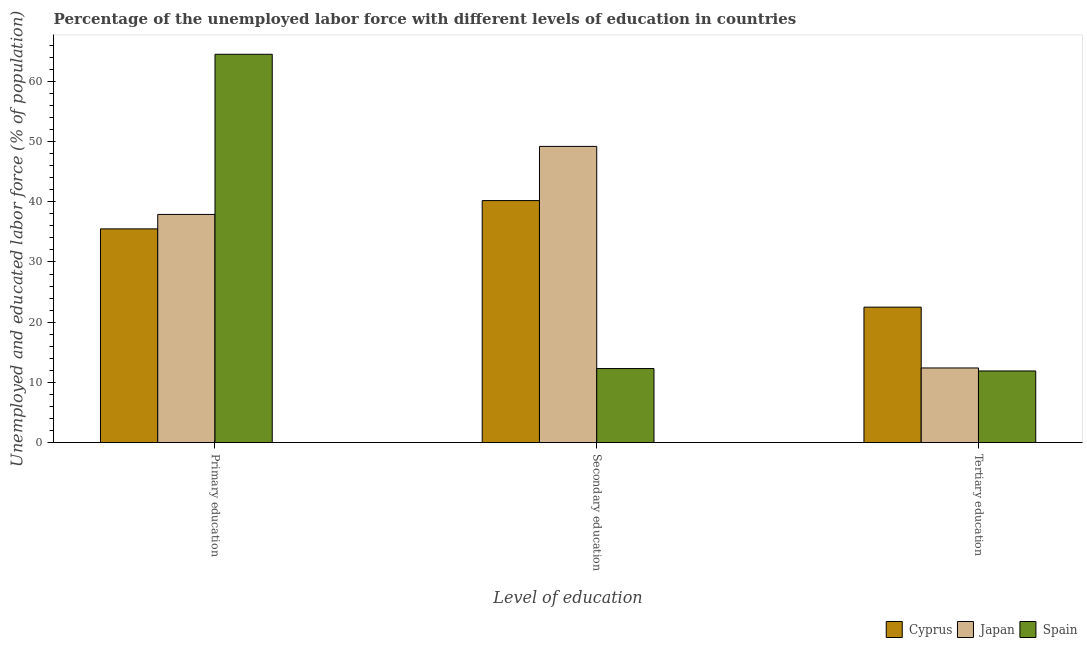How many different coloured bars are there?
Your answer should be very brief. 3. How many groups of bars are there?
Make the answer very short. 3. Are the number of bars on each tick of the X-axis equal?
Your answer should be very brief. Yes. How many bars are there on the 3rd tick from the left?
Your answer should be very brief. 3. How many bars are there on the 1st tick from the right?
Offer a very short reply. 3. What is the label of the 2nd group of bars from the left?
Your answer should be very brief. Secondary education. What is the percentage of labor force who received secondary education in Spain?
Offer a terse response. 12.3. Across all countries, what is the maximum percentage of labor force who received secondary education?
Your answer should be very brief. 49.2. Across all countries, what is the minimum percentage of labor force who received primary education?
Provide a short and direct response. 35.5. In which country was the percentage of labor force who received secondary education minimum?
Offer a terse response. Spain. What is the total percentage of labor force who received tertiary education in the graph?
Offer a terse response. 46.8. What is the difference between the percentage of labor force who received tertiary education in Spain and that in Cyprus?
Offer a very short reply. -10.6. What is the difference between the percentage of labor force who received primary education in Spain and the percentage of labor force who received tertiary education in Cyprus?
Your answer should be compact. 42. What is the average percentage of labor force who received secondary education per country?
Your answer should be very brief. 33.9. What is the difference between the percentage of labor force who received tertiary education and percentage of labor force who received primary education in Japan?
Offer a very short reply. -25.5. What is the ratio of the percentage of labor force who received primary education in Japan to that in Cyprus?
Keep it short and to the point. 1.07. Is the percentage of labor force who received secondary education in Japan less than that in Cyprus?
Your response must be concise. No. Is the difference between the percentage of labor force who received primary education in Japan and Spain greater than the difference between the percentage of labor force who received secondary education in Japan and Spain?
Your answer should be compact. No. What is the difference between the highest and the second highest percentage of labor force who received tertiary education?
Provide a short and direct response. 10.1. In how many countries, is the percentage of labor force who received secondary education greater than the average percentage of labor force who received secondary education taken over all countries?
Provide a succinct answer. 2. What does the 3rd bar from the left in Tertiary education represents?
Your answer should be compact. Spain. What does the 1st bar from the right in Primary education represents?
Keep it short and to the point. Spain. How many countries are there in the graph?
Keep it short and to the point. 3. Where does the legend appear in the graph?
Keep it short and to the point. Bottom right. How many legend labels are there?
Your answer should be very brief. 3. What is the title of the graph?
Your response must be concise. Percentage of the unemployed labor force with different levels of education in countries. What is the label or title of the X-axis?
Offer a very short reply. Level of education. What is the label or title of the Y-axis?
Offer a very short reply. Unemployed and educated labor force (% of population). What is the Unemployed and educated labor force (% of population) in Cyprus in Primary education?
Offer a very short reply. 35.5. What is the Unemployed and educated labor force (% of population) in Japan in Primary education?
Give a very brief answer. 37.9. What is the Unemployed and educated labor force (% of population) in Spain in Primary education?
Offer a terse response. 64.5. What is the Unemployed and educated labor force (% of population) of Cyprus in Secondary education?
Keep it short and to the point. 40.2. What is the Unemployed and educated labor force (% of population) in Japan in Secondary education?
Ensure brevity in your answer.  49.2. What is the Unemployed and educated labor force (% of population) of Spain in Secondary education?
Your answer should be very brief. 12.3. What is the Unemployed and educated labor force (% of population) in Japan in Tertiary education?
Your answer should be compact. 12.4. What is the Unemployed and educated labor force (% of population) of Spain in Tertiary education?
Provide a succinct answer. 11.9. Across all Level of education, what is the maximum Unemployed and educated labor force (% of population) of Cyprus?
Ensure brevity in your answer.  40.2. Across all Level of education, what is the maximum Unemployed and educated labor force (% of population) of Japan?
Offer a very short reply. 49.2. Across all Level of education, what is the maximum Unemployed and educated labor force (% of population) in Spain?
Offer a very short reply. 64.5. Across all Level of education, what is the minimum Unemployed and educated labor force (% of population) in Japan?
Ensure brevity in your answer.  12.4. Across all Level of education, what is the minimum Unemployed and educated labor force (% of population) in Spain?
Offer a terse response. 11.9. What is the total Unemployed and educated labor force (% of population) of Cyprus in the graph?
Make the answer very short. 98.2. What is the total Unemployed and educated labor force (% of population) of Japan in the graph?
Your response must be concise. 99.5. What is the total Unemployed and educated labor force (% of population) of Spain in the graph?
Your answer should be very brief. 88.7. What is the difference between the Unemployed and educated labor force (% of population) in Spain in Primary education and that in Secondary education?
Provide a succinct answer. 52.2. What is the difference between the Unemployed and educated labor force (% of population) in Cyprus in Primary education and that in Tertiary education?
Your response must be concise. 13. What is the difference between the Unemployed and educated labor force (% of population) of Spain in Primary education and that in Tertiary education?
Provide a succinct answer. 52.6. What is the difference between the Unemployed and educated labor force (% of population) in Cyprus in Secondary education and that in Tertiary education?
Your answer should be very brief. 17.7. What is the difference between the Unemployed and educated labor force (% of population) in Japan in Secondary education and that in Tertiary education?
Offer a terse response. 36.8. What is the difference between the Unemployed and educated labor force (% of population) in Spain in Secondary education and that in Tertiary education?
Provide a short and direct response. 0.4. What is the difference between the Unemployed and educated labor force (% of population) of Cyprus in Primary education and the Unemployed and educated labor force (% of population) of Japan in Secondary education?
Offer a terse response. -13.7. What is the difference between the Unemployed and educated labor force (% of population) of Cyprus in Primary education and the Unemployed and educated labor force (% of population) of Spain in Secondary education?
Your answer should be very brief. 23.2. What is the difference between the Unemployed and educated labor force (% of population) in Japan in Primary education and the Unemployed and educated labor force (% of population) in Spain in Secondary education?
Provide a succinct answer. 25.6. What is the difference between the Unemployed and educated labor force (% of population) in Cyprus in Primary education and the Unemployed and educated labor force (% of population) in Japan in Tertiary education?
Your answer should be very brief. 23.1. What is the difference between the Unemployed and educated labor force (% of population) in Cyprus in Primary education and the Unemployed and educated labor force (% of population) in Spain in Tertiary education?
Offer a terse response. 23.6. What is the difference between the Unemployed and educated labor force (% of population) of Japan in Primary education and the Unemployed and educated labor force (% of population) of Spain in Tertiary education?
Offer a very short reply. 26. What is the difference between the Unemployed and educated labor force (% of population) in Cyprus in Secondary education and the Unemployed and educated labor force (% of population) in Japan in Tertiary education?
Provide a succinct answer. 27.8. What is the difference between the Unemployed and educated labor force (% of population) in Cyprus in Secondary education and the Unemployed and educated labor force (% of population) in Spain in Tertiary education?
Your answer should be very brief. 28.3. What is the difference between the Unemployed and educated labor force (% of population) in Japan in Secondary education and the Unemployed and educated labor force (% of population) in Spain in Tertiary education?
Offer a terse response. 37.3. What is the average Unemployed and educated labor force (% of population) in Cyprus per Level of education?
Offer a terse response. 32.73. What is the average Unemployed and educated labor force (% of population) in Japan per Level of education?
Make the answer very short. 33.17. What is the average Unemployed and educated labor force (% of population) in Spain per Level of education?
Provide a short and direct response. 29.57. What is the difference between the Unemployed and educated labor force (% of population) of Japan and Unemployed and educated labor force (% of population) of Spain in Primary education?
Ensure brevity in your answer.  -26.6. What is the difference between the Unemployed and educated labor force (% of population) of Cyprus and Unemployed and educated labor force (% of population) of Japan in Secondary education?
Your response must be concise. -9. What is the difference between the Unemployed and educated labor force (% of population) of Cyprus and Unemployed and educated labor force (% of population) of Spain in Secondary education?
Your answer should be compact. 27.9. What is the difference between the Unemployed and educated labor force (% of population) of Japan and Unemployed and educated labor force (% of population) of Spain in Secondary education?
Provide a short and direct response. 36.9. What is the difference between the Unemployed and educated labor force (% of population) in Cyprus and Unemployed and educated labor force (% of population) in Japan in Tertiary education?
Provide a succinct answer. 10.1. What is the difference between the Unemployed and educated labor force (% of population) in Cyprus and Unemployed and educated labor force (% of population) in Spain in Tertiary education?
Your answer should be very brief. 10.6. What is the difference between the Unemployed and educated labor force (% of population) in Japan and Unemployed and educated labor force (% of population) in Spain in Tertiary education?
Make the answer very short. 0.5. What is the ratio of the Unemployed and educated labor force (% of population) in Cyprus in Primary education to that in Secondary education?
Provide a succinct answer. 0.88. What is the ratio of the Unemployed and educated labor force (% of population) in Japan in Primary education to that in Secondary education?
Provide a short and direct response. 0.77. What is the ratio of the Unemployed and educated labor force (% of population) of Spain in Primary education to that in Secondary education?
Your answer should be compact. 5.24. What is the ratio of the Unemployed and educated labor force (% of population) in Cyprus in Primary education to that in Tertiary education?
Provide a succinct answer. 1.58. What is the ratio of the Unemployed and educated labor force (% of population) in Japan in Primary education to that in Tertiary education?
Your answer should be compact. 3.06. What is the ratio of the Unemployed and educated labor force (% of population) of Spain in Primary education to that in Tertiary education?
Keep it short and to the point. 5.42. What is the ratio of the Unemployed and educated labor force (% of population) in Cyprus in Secondary education to that in Tertiary education?
Make the answer very short. 1.79. What is the ratio of the Unemployed and educated labor force (% of population) of Japan in Secondary education to that in Tertiary education?
Your answer should be very brief. 3.97. What is the ratio of the Unemployed and educated labor force (% of population) in Spain in Secondary education to that in Tertiary education?
Provide a short and direct response. 1.03. What is the difference between the highest and the second highest Unemployed and educated labor force (% of population) of Spain?
Your answer should be very brief. 52.2. What is the difference between the highest and the lowest Unemployed and educated labor force (% of population) in Cyprus?
Your answer should be compact. 17.7. What is the difference between the highest and the lowest Unemployed and educated labor force (% of population) in Japan?
Your answer should be compact. 36.8. What is the difference between the highest and the lowest Unemployed and educated labor force (% of population) of Spain?
Offer a very short reply. 52.6. 